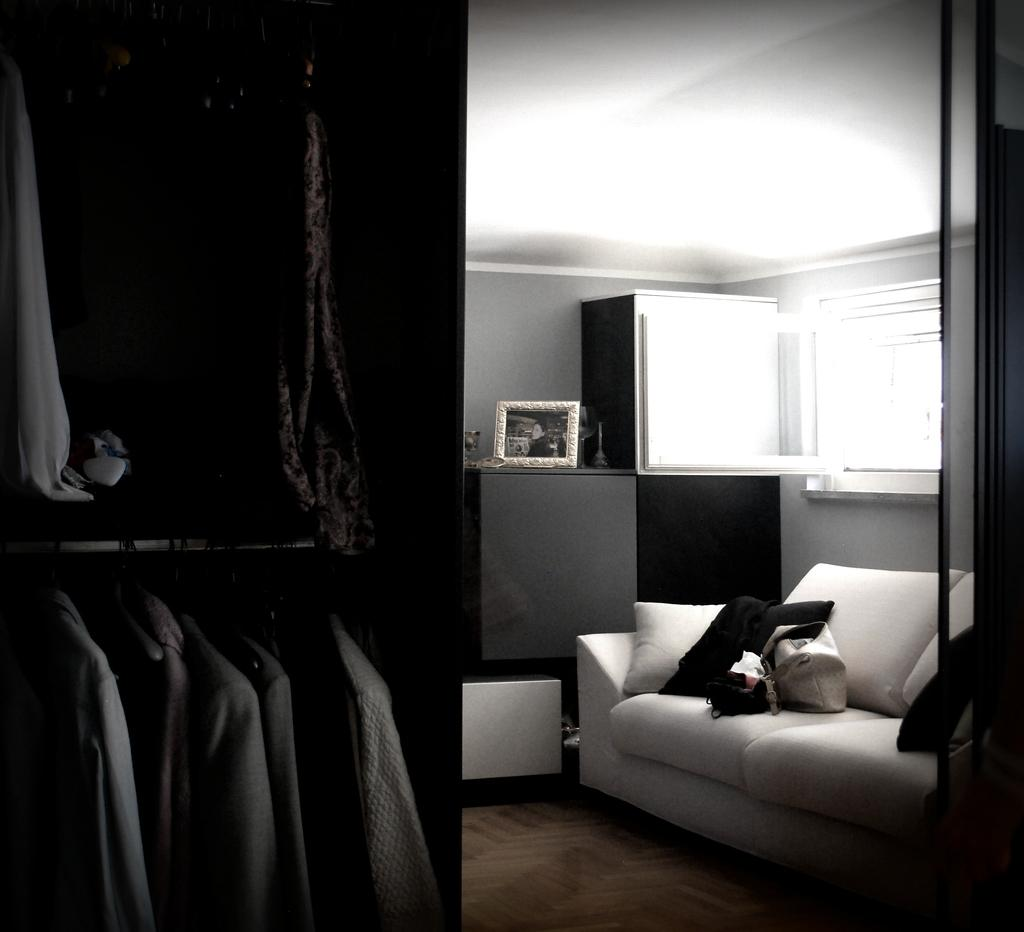What type of vehicle is in the image? There is a coach in the image. What personal item can be seen in the image? There is a handbag in the image. What type of furniture is in the image? There is a pillow in the image. What type of storage unit is in the image? There is a cupboard in the image. What is stored inside the cupboard? Clothing is stored in the cupboard. What type of decorative item is in the image? There is a frame in the image. How many insects are crawling on the coach in the image? There are no insects visible in the image. What type of shell is present on the pillow in the image? There is no shell or any reference to a jam-like substance in the image. 